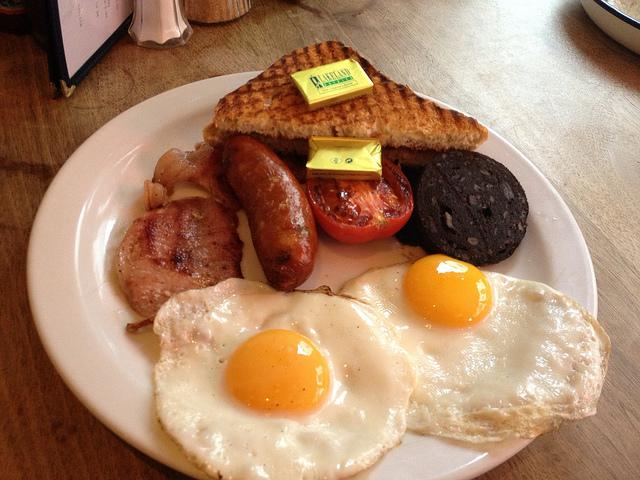How many eggs are served in this breakfast overeasy? two 